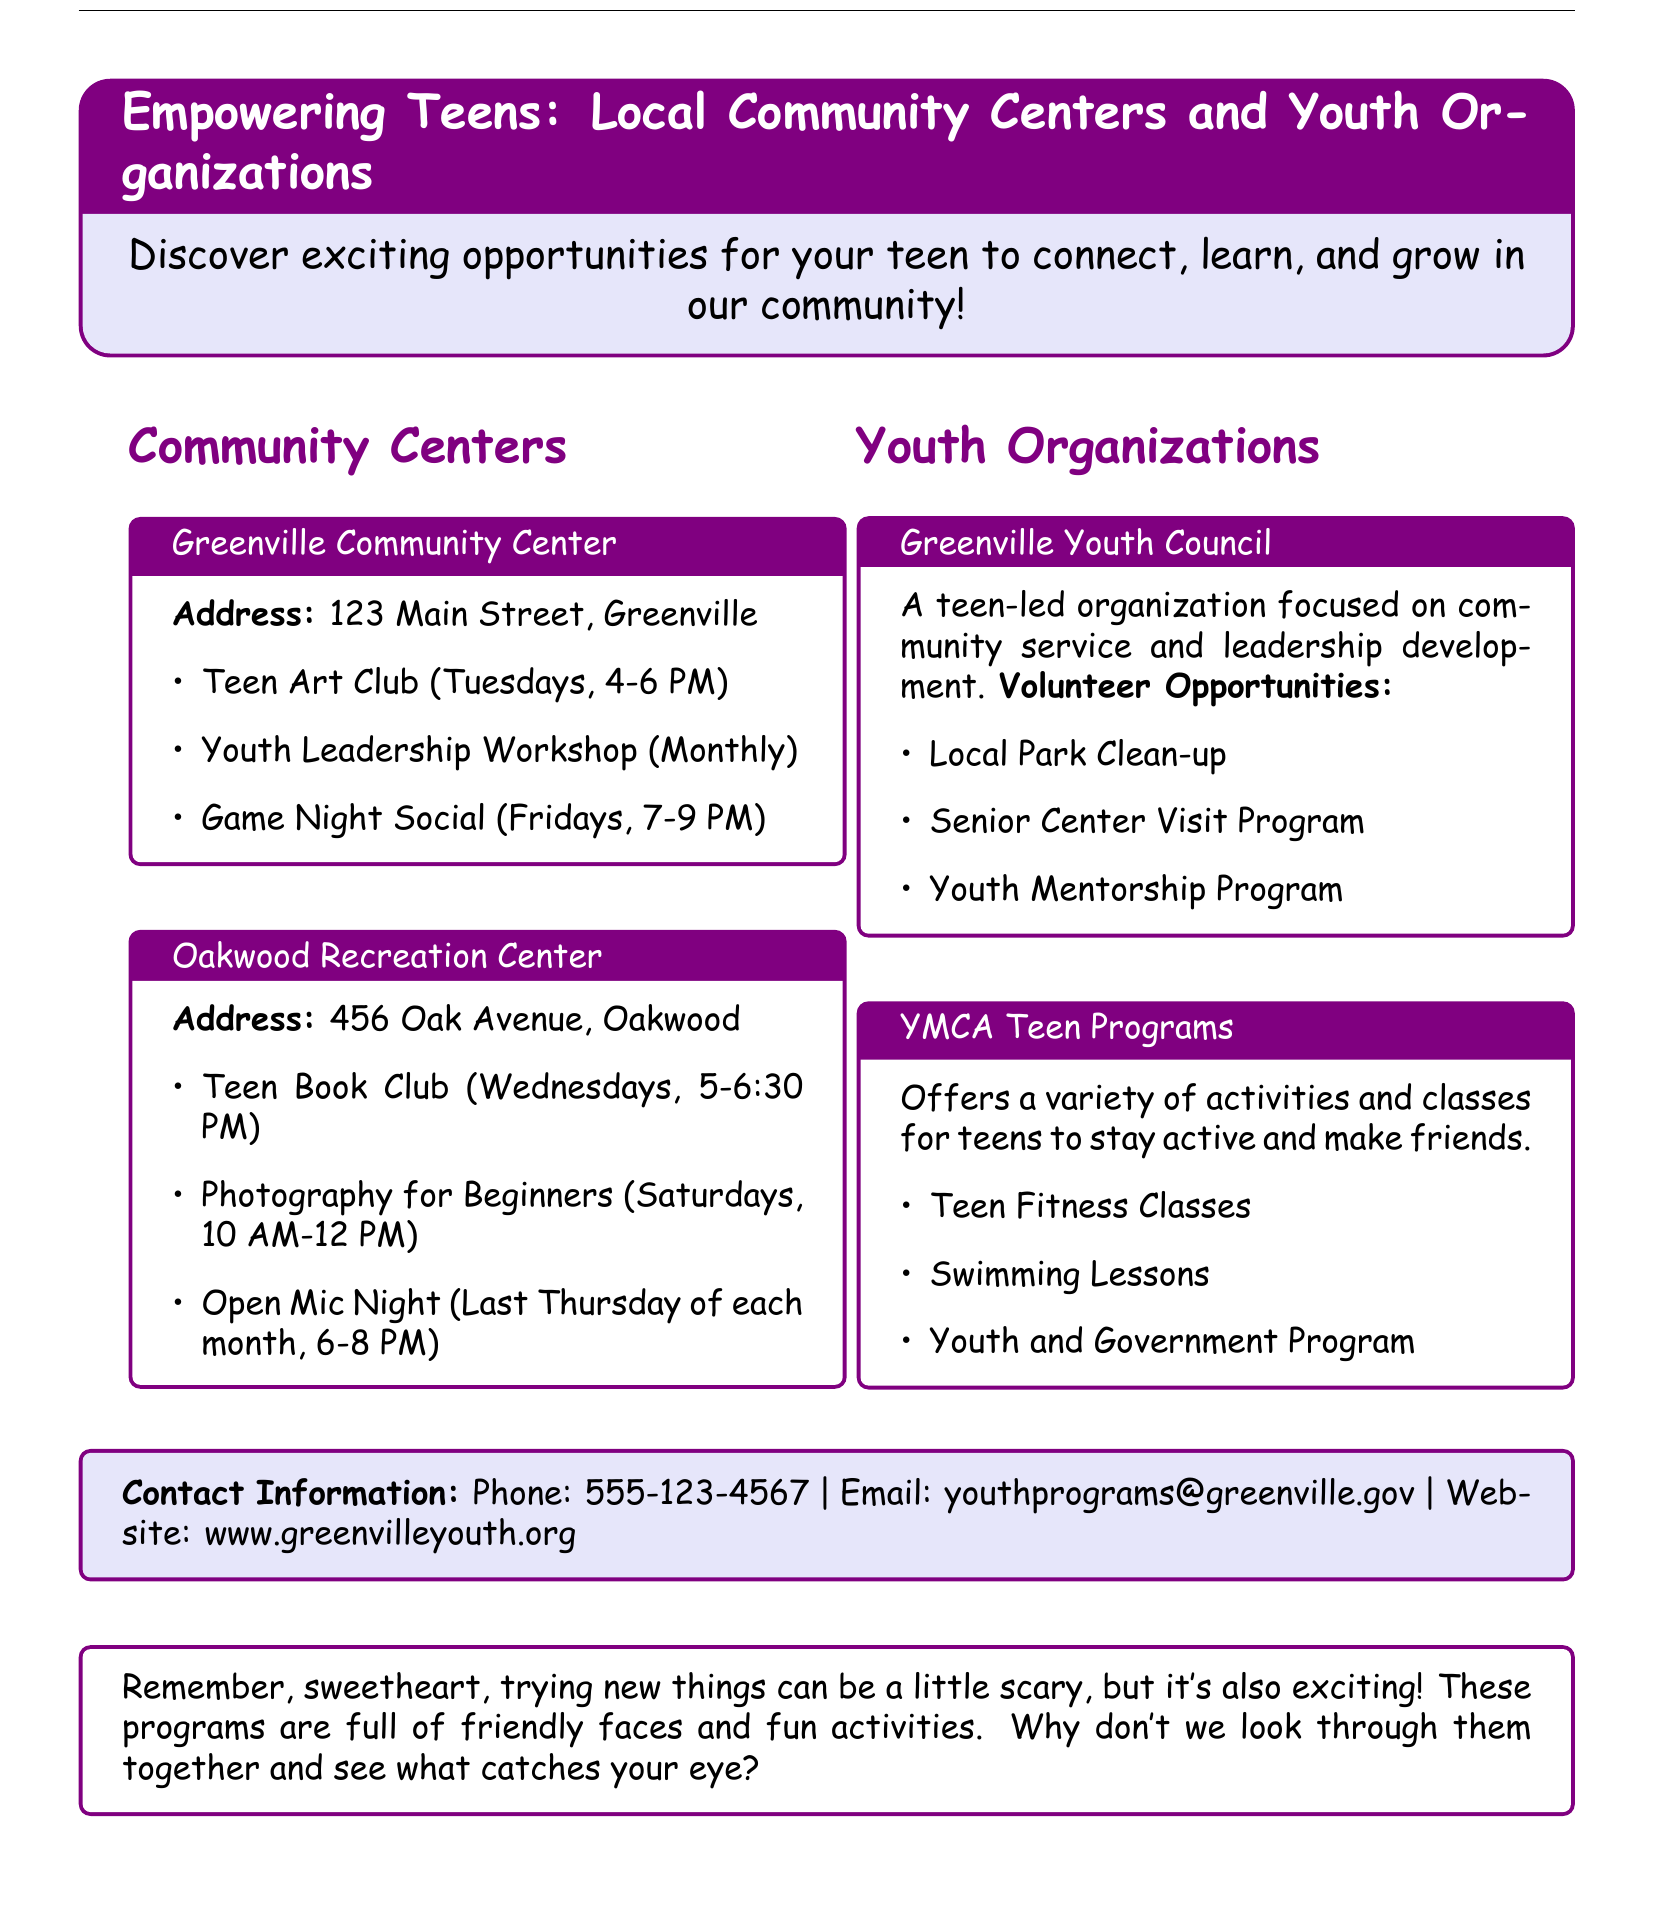What programs are available at Greenville Community Center? The document lists several programs at the Greenville Community Center including the Teen Art Club, Youth Leadership Workshop, and Game Night Social.
Answer: Teen Art Club, Youth Leadership Workshop, Game Night Social When does the Open Mic Night take place? The Open Mic Night is scheduled for the last Thursday of each month from 6-8 PM.
Answer: Last Thursday of each month What is the address of Oakwood Recreation Center? The document specifies the address of the Oakwood Recreation Center as 456 Oak Avenue, Oakwood.
Answer: 456 Oak Avenue, Oakwood What is the primary focus of the Greenville Youth Council? The Greenville Youth Council is a teen-led organization focused on community service and leadership development.
Answer: Community service and leadership development How often does the Youth Leadership Workshop occur? The document states that the Youth Leadership Workshop occurs monthly.
Answer: Monthly What volunteer opportunity involves senior citizens? One of the volunteer opportunities mentioned is the Senior Center Visit Program.
Answer: Senior Center Visit Program What type of classes does YMCA offer for teens? The document mentions Teen Fitness Classes, which are part of the YMCA Teen Programs.
Answer: Teen Fitness Classes What is the phone number for youth programs? The document provides the phone number for youth programs as 555-123-4567.
Answer: 555-123-4567 